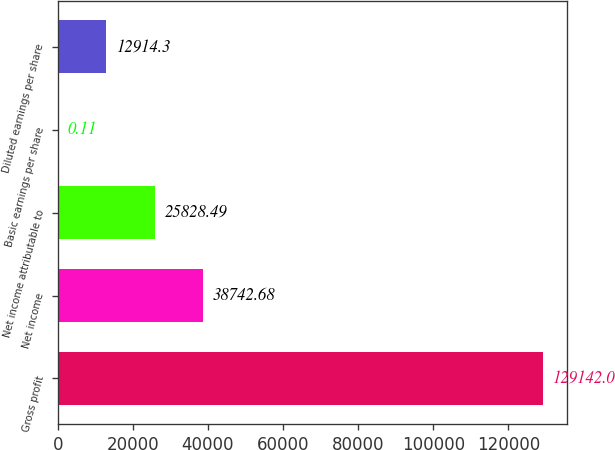<chart> <loc_0><loc_0><loc_500><loc_500><bar_chart><fcel>Gross profit<fcel>Net income<fcel>Net income attributable to<fcel>Basic earnings per share<fcel>Diluted earnings per share<nl><fcel>129142<fcel>38742.7<fcel>25828.5<fcel>0.11<fcel>12914.3<nl></chart> 